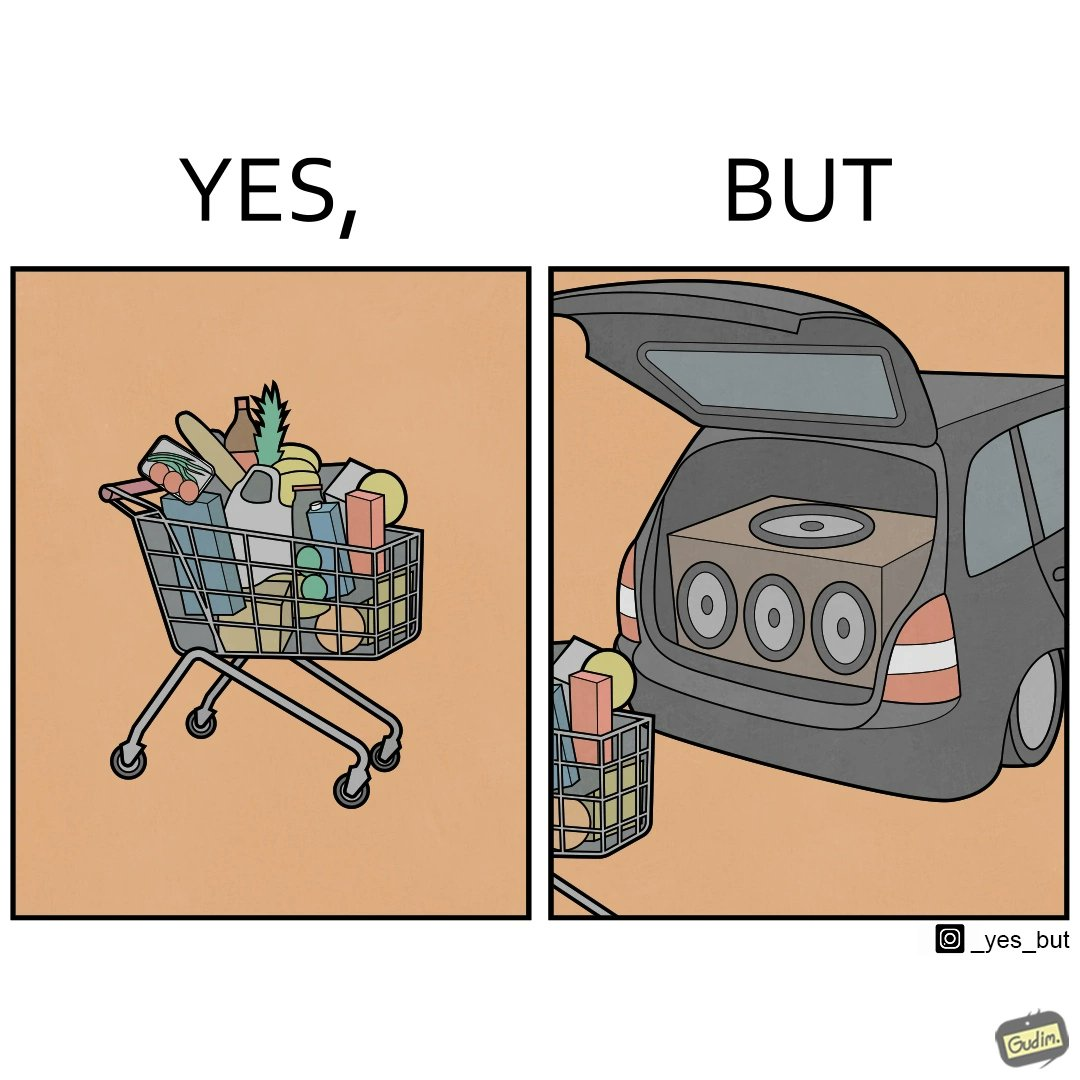Describe the contrast between the left and right parts of this image. In the left part of the image: a shopping cart full of items In the right part of the image: a black car with its trunk lid open and some boxes, probably speakers, kept in the trunk 